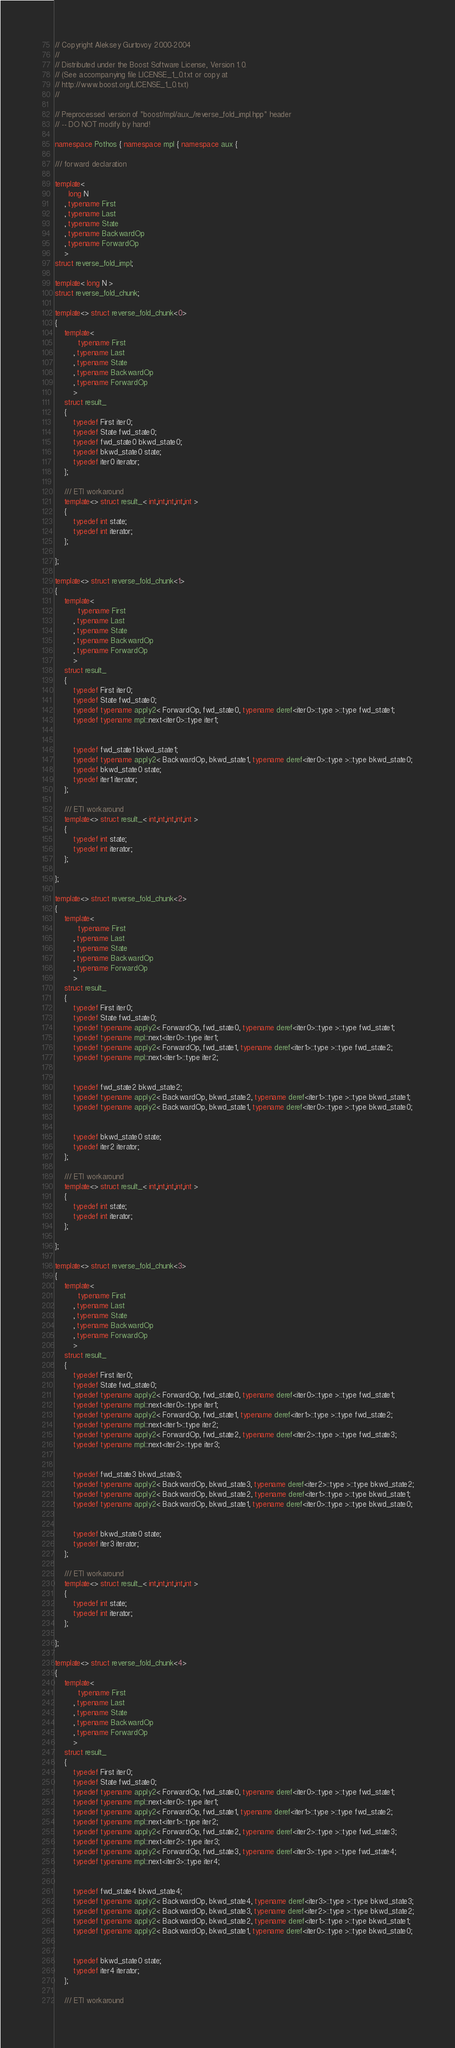Convert code to text. <code><loc_0><loc_0><loc_500><loc_500><_C++_>
// Copyright Aleksey Gurtovoy 2000-2004
//
// Distributed under the Boost Software License, Version 1.0. 
// (See accompanying file LICENSE_1_0.txt or copy at 
// http://www.boost.org/LICENSE_1_0.txt)
//

// Preprocessed version of "boost/mpl/aux_/reverse_fold_impl.hpp" header
// -- DO NOT modify by hand!

namespace Pothos { namespace mpl { namespace aux {

/// forward declaration

template<
      long N
    , typename First
    , typename Last
    , typename State
    , typename BackwardOp
    , typename ForwardOp
    >
struct reverse_fold_impl;

template< long N >
struct reverse_fold_chunk;

template<> struct reverse_fold_chunk<0>
{
    template<
          typename First
        , typename Last
        , typename State
        , typename BackwardOp
        , typename ForwardOp
        >
    struct result_
    {
        typedef First iter0;
        typedef State fwd_state0;
        typedef fwd_state0 bkwd_state0;
        typedef bkwd_state0 state;
        typedef iter0 iterator;
    };

    /// ETI workaround
    template<> struct result_< int,int,int,int,int >
    {
        typedef int state;
        typedef int iterator;
    };

};

template<> struct reverse_fold_chunk<1>
{
    template<
          typename First
        , typename Last
        , typename State
        , typename BackwardOp
        , typename ForwardOp
        >
    struct result_
    {
        typedef First iter0;
        typedef State fwd_state0;
        typedef typename apply2< ForwardOp, fwd_state0, typename deref<iter0>::type >::type fwd_state1;
        typedef typename mpl::next<iter0>::type iter1;
        

        typedef fwd_state1 bkwd_state1;
        typedef typename apply2< BackwardOp, bkwd_state1, typename deref<iter0>::type >::type bkwd_state0;
        typedef bkwd_state0 state;
        typedef iter1 iterator;
    };

    /// ETI workaround
    template<> struct result_< int,int,int,int,int >
    {
        typedef int state;
        typedef int iterator;
    };

};

template<> struct reverse_fold_chunk<2>
{
    template<
          typename First
        , typename Last
        , typename State
        , typename BackwardOp
        , typename ForwardOp
        >
    struct result_
    {
        typedef First iter0;
        typedef State fwd_state0;
        typedef typename apply2< ForwardOp, fwd_state0, typename deref<iter0>::type >::type fwd_state1;
        typedef typename mpl::next<iter0>::type iter1;
        typedef typename apply2< ForwardOp, fwd_state1, typename deref<iter1>::type >::type fwd_state2;
        typedef typename mpl::next<iter1>::type iter2;
        

        typedef fwd_state2 bkwd_state2;
        typedef typename apply2< BackwardOp, bkwd_state2, typename deref<iter1>::type >::type bkwd_state1;
        typedef typename apply2< BackwardOp, bkwd_state1, typename deref<iter0>::type >::type bkwd_state0;
        

        typedef bkwd_state0 state;
        typedef iter2 iterator;
    };

    /// ETI workaround
    template<> struct result_< int,int,int,int,int >
    {
        typedef int state;
        typedef int iterator;
    };

};

template<> struct reverse_fold_chunk<3>
{
    template<
          typename First
        , typename Last
        , typename State
        , typename BackwardOp
        , typename ForwardOp
        >
    struct result_
    {
        typedef First iter0;
        typedef State fwd_state0;
        typedef typename apply2< ForwardOp, fwd_state0, typename deref<iter0>::type >::type fwd_state1;
        typedef typename mpl::next<iter0>::type iter1;
        typedef typename apply2< ForwardOp, fwd_state1, typename deref<iter1>::type >::type fwd_state2;
        typedef typename mpl::next<iter1>::type iter2;
        typedef typename apply2< ForwardOp, fwd_state2, typename deref<iter2>::type >::type fwd_state3;
        typedef typename mpl::next<iter2>::type iter3;
        

        typedef fwd_state3 bkwd_state3;
        typedef typename apply2< BackwardOp, bkwd_state3, typename deref<iter2>::type >::type bkwd_state2;
        typedef typename apply2< BackwardOp, bkwd_state2, typename deref<iter1>::type >::type bkwd_state1;
        typedef typename apply2< BackwardOp, bkwd_state1, typename deref<iter0>::type >::type bkwd_state0;
        

        typedef bkwd_state0 state;
        typedef iter3 iterator;
    };

    /// ETI workaround
    template<> struct result_< int,int,int,int,int >
    {
        typedef int state;
        typedef int iterator;
    };

};

template<> struct reverse_fold_chunk<4>
{
    template<
          typename First
        , typename Last
        , typename State
        , typename BackwardOp
        , typename ForwardOp
        >
    struct result_
    {
        typedef First iter0;
        typedef State fwd_state0;
        typedef typename apply2< ForwardOp, fwd_state0, typename deref<iter0>::type >::type fwd_state1;
        typedef typename mpl::next<iter0>::type iter1;
        typedef typename apply2< ForwardOp, fwd_state1, typename deref<iter1>::type >::type fwd_state2;
        typedef typename mpl::next<iter1>::type iter2;
        typedef typename apply2< ForwardOp, fwd_state2, typename deref<iter2>::type >::type fwd_state3;
        typedef typename mpl::next<iter2>::type iter3;
        typedef typename apply2< ForwardOp, fwd_state3, typename deref<iter3>::type >::type fwd_state4;
        typedef typename mpl::next<iter3>::type iter4;
        

        typedef fwd_state4 bkwd_state4;
        typedef typename apply2< BackwardOp, bkwd_state4, typename deref<iter3>::type >::type bkwd_state3;
        typedef typename apply2< BackwardOp, bkwd_state3, typename deref<iter2>::type >::type bkwd_state2;
        typedef typename apply2< BackwardOp, bkwd_state2, typename deref<iter1>::type >::type bkwd_state1;
        typedef typename apply2< BackwardOp, bkwd_state1, typename deref<iter0>::type >::type bkwd_state0;
        

        typedef bkwd_state0 state;
        typedef iter4 iterator;
    };

    /// ETI workaround</code> 